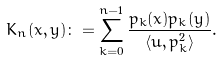<formula> <loc_0><loc_0><loc_500><loc_500>K _ { n } ( x , y ) \colon = \sum _ { k = 0 } ^ { n - 1 } \frac { p _ { k } ( x ) p _ { k } ( y ) } { \langle { u } , p ^ { 2 } _ { k } \rangle } .</formula> 